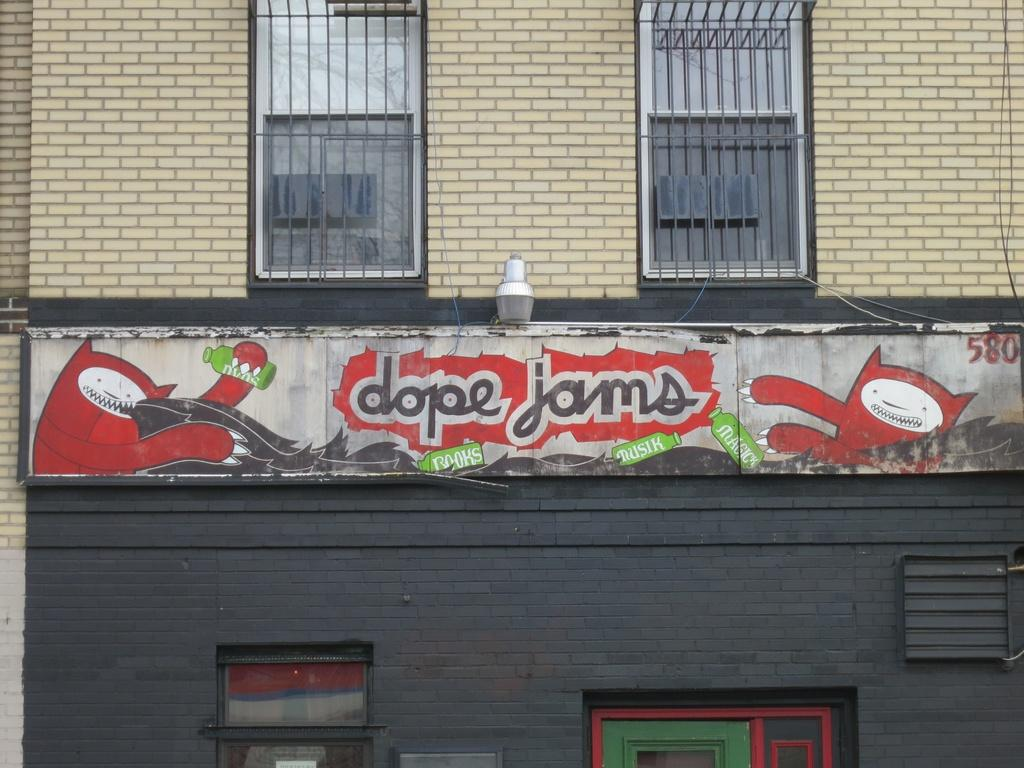What type of structure is visible in the image? There is a building in the image. What feature can be seen on the building? The building has windows. Is there any signage visible on the building? Yes, there is a name board in the image. What type of lighting is present in the image? A lamp is attached to the wall in the image. How can the building be accessed? There is a door in the image. What is the texture of the wall in the image? The wall has a brick texture. What type of metal is used to construct the space station in the image? There is no space station present in the image; it features a building with a brick wall, windows, a name board, a lamp, and a door. 